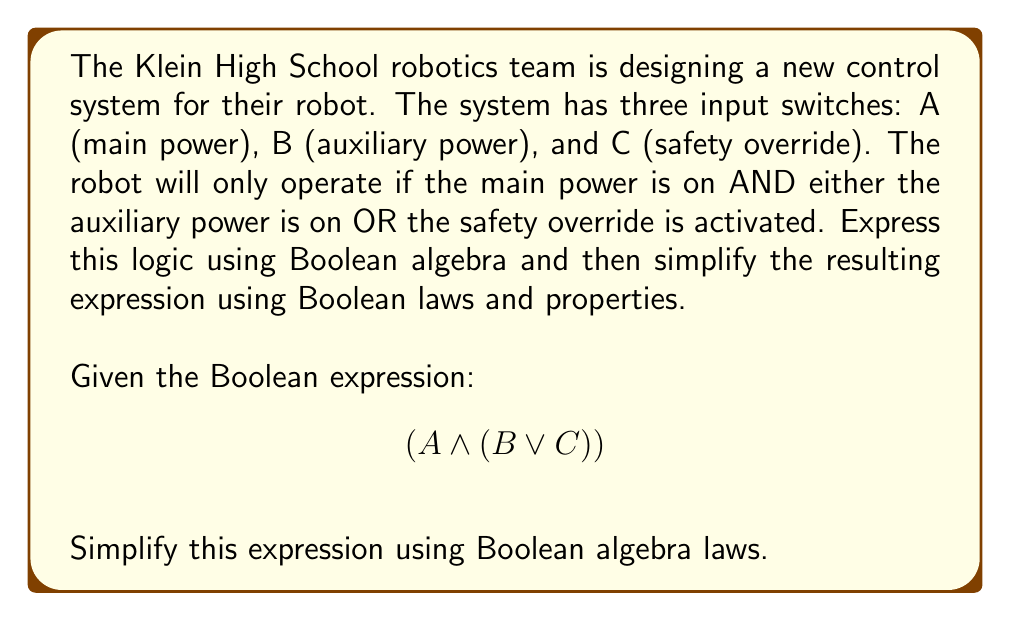Can you answer this question? Let's approach this step-by-step:

1) First, we need to recognize that the given expression $$(A \land (B \lor C))$$ is already in its simplest form according to Boolean algebra laws. This is because:

   a) The expression uses only AND ($\land$) and OR ($\lor$) operations.
   b) The OR operation is contained within parentheses, which is necessary to maintain the correct order of operations.

2) We can verify this by applying the distributive law of Boolean algebra:

   $$(A \land (B \lor C)) = (A \land B) \lor (A \land C)$$

   However, this actually expands the expression rather than simplifying it.

3) We can also consider the commutative property:

   $$(A \land (B \lor C)) = ((B \lor C) \land A)$$

   But this doesn't simplify the expression either; it merely changes the order.

4) The associative property doesn't apply here because we don't have three terms connected by the same operation.

5) The absorption law $(A \lor (A \land B) = A)$ and the idempotent law $(A \land A = A)$ don't apply to this expression.

Therefore, the original expression $$(A \land (B \lor C))$$ is already in its simplest form according to Boolean algebra laws.
Answer: $$(A \land (B \lor C))$$ 